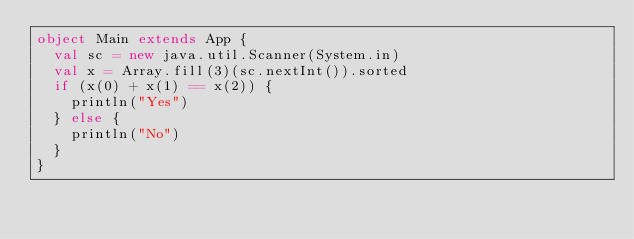Convert code to text. <code><loc_0><loc_0><loc_500><loc_500><_Scala_>object Main extends App {
  val sc = new java.util.Scanner(System.in)
  val x = Array.fill(3)(sc.nextInt()).sorted
  if (x(0) + x(1) == x(2)) {
    println("Yes")
  } else {
    println("No")
  }
}
</code> 